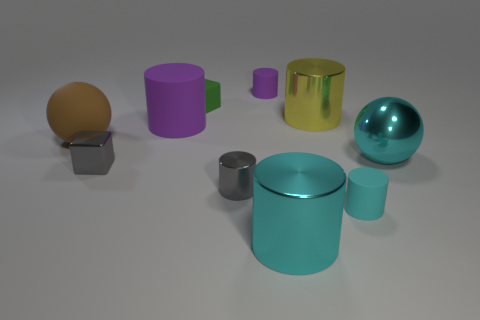Subtract all gray metallic cylinders. How many cylinders are left? 5 Subtract all brown balls. How many balls are left? 1 Subtract 1 cyan spheres. How many objects are left? 9 Subtract all cubes. How many objects are left? 8 Subtract all brown cylinders. Subtract all cyan blocks. How many cylinders are left? 6 Subtract all green cylinders. How many brown balls are left? 1 Subtract all gray cylinders. Subtract all large red matte objects. How many objects are left? 9 Add 9 cyan matte cylinders. How many cyan matte cylinders are left? 10 Add 10 green rubber balls. How many green rubber balls exist? 10 